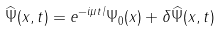<formula> <loc_0><loc_0><loc_500><loc_500>\widehat { \Psi } ( x , t ) = e ^ { - i \mu t / } \Psi _ { 0 } ( x ) + \delta \widehat { \Psi } ( x , t )</formula> 